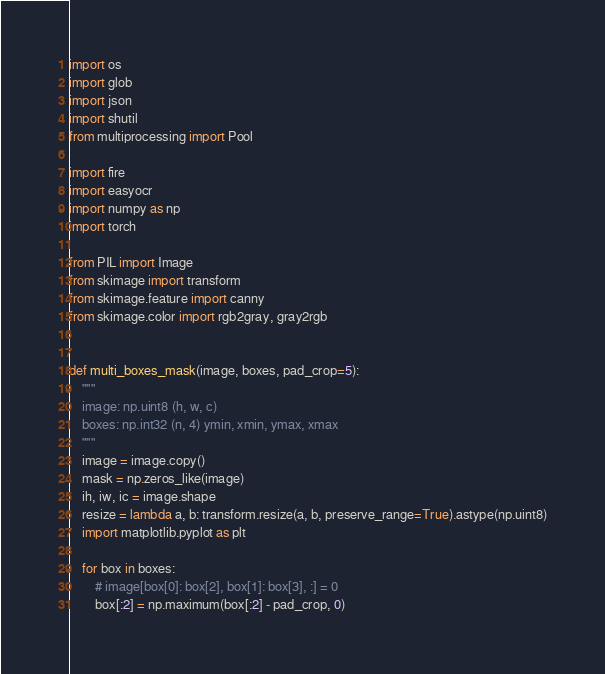Convert code to text. <code><loc_0><loc_0><loc_500><loc_500><_Python_>import os
import glob
import json
import shutil
from multiprocessing import Pool

import fire
import easyocr
import numpy as np
import torch

from PIL import Image
from skimage import transform
from skimage.feature import canny
from skimage.color import rgb2gray, gray2rgb


def multi_boxes_mask(image, boxes, pad_crop=5):
    """
    image: np.uint8 (h, w, c)
    boxes: np.int32 (n, 4) ymin, xmin, ymax, xmax
    """
    image = image.copy()
    mask = np.zeros_like(image)
    ih, iw, ic = image.shape
    resize = lambda a, b: transform.resize(a, b, preserve_range=True).astype(np.uint8)
    import matplotlib.pyplot as plt
    
    for box in boxes:
        # image[box[0]: box[2], box[1]: box[3], :] = 0
        box[:2] = np.maximum(box[:2] - pad_crop, 0)</code> 